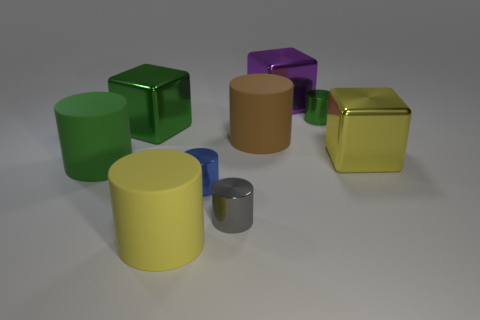What is the size of the metal block that is to the left of the large rubber object that is right of the metal object that is in front of the small blue cylinder?
Make the answer very short. Large. How many rubber objects are either cylinders or large gray cylinders?
Make the answer very short. 3. There is a gray object; does it have the same shape as the big shiny object in front of the large brown matte cylinder?
Give a very brief answer. No. Are there more big yellow cubes that are on the left side of the yellow matte cylinder than big green blocks in front of the green block?
Provide a succinct answer. No. There is a tiny gray cylinder on the right side of the large green shiny block right of the large green cylinder; are there any large purple blocks in front of it?
Offer a terse response. No. There is a matte object in front of the gray object; does it have the same shape as the large purple metallic thing?
Ensure brevity in your answer.  No. Are there fewer blue objects in front of the blue metallic object than gray shiny cylinders behind the yellow metallic cube?
Your answer should be very brief. No. What material is the small green thing?
Give a very brief answer. Metal. There is a brown object; what number of small blue objects are in front of it?
Make the answer very short. 1. Are there fewer green metal cubes behind the small green cylinder than small gray cylinders?
Your answer should be very brief. Yes. 